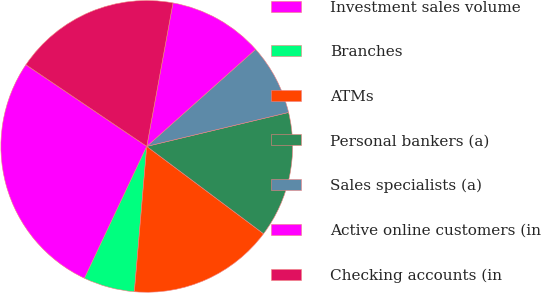Convert chart. <chart><loc_0><loc_0><loc_500><loc_500><pie_chart><fcel>Investment sales volume<fcel>Branches<fcel>ATMs<fcel>Personal bankers (a)<fcel>Sales specialists (a)<fcel>Active online customers (in<fcel>Checking accounts (in<nl><fcel>27.43%<fcel>5.67%<fcel>16.13%<fcel>13.96%<fcel>7.85%<fcel>10.53%<fcel>18.42%<nl></chart> 